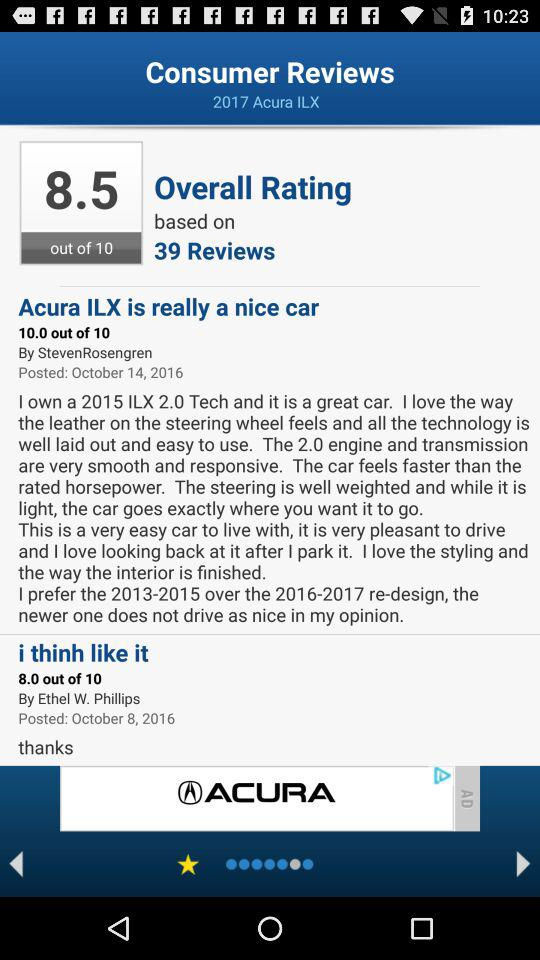What's the total number of reviews on which the overall rating is based? The total number of reviews is 39. 